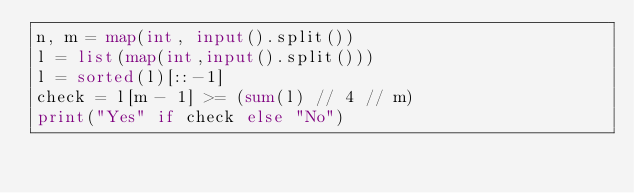<code> <loc_0><loc_0><loc_500><loc_500><_Python_>n, m = map(int, input().split())
l = list(map(int,input().split()))
l = sorted(l)[::-1]
check = l[m - 1] >= (sum(l) // 4 // m)
print("Yes" if check else "No")</code> 